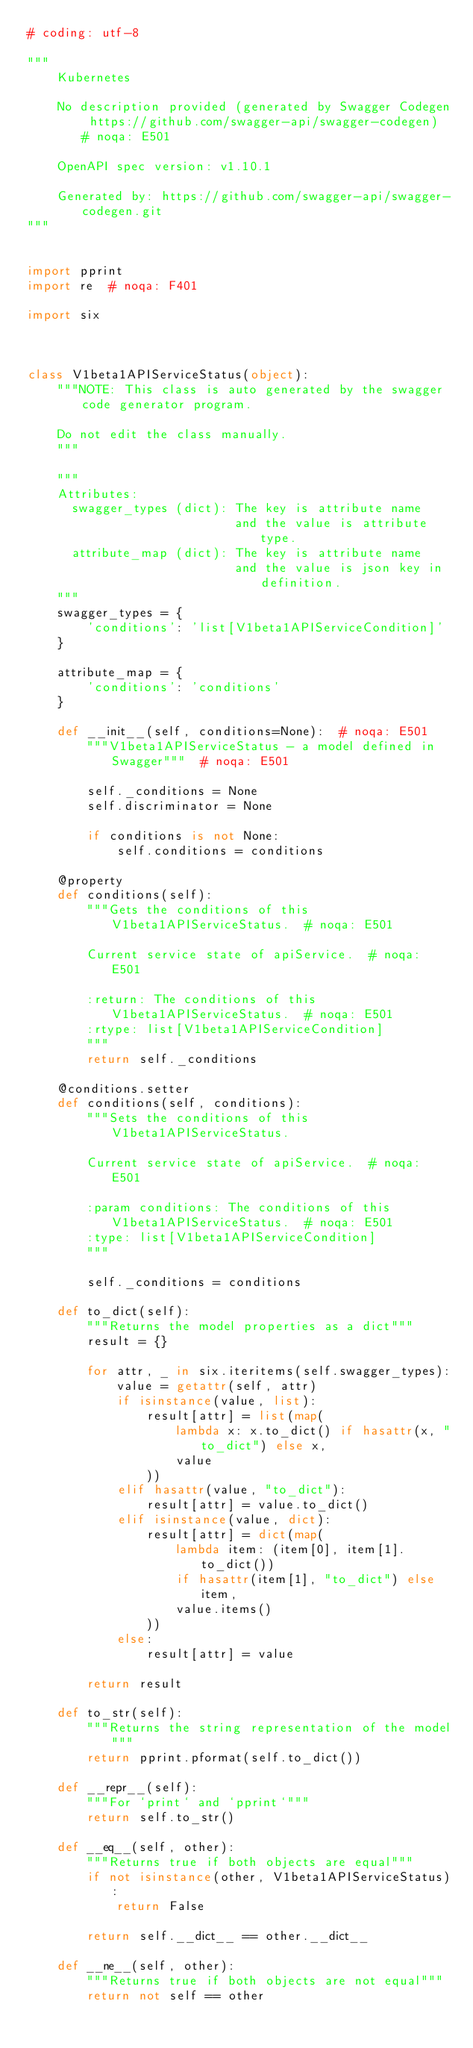Convert code to text. <code><loc_0><loc_0><loc_500><loc_500><_Python_># coding: utf-8

"""
    Kubernetes

    No description provided (generated by Swagger Codegen https://github.com/swagger-api/swagger-codegen)  # noqa: E501

    OpenAPI spec version: v1.10.1
    
    Generated by: https://github.com/swagger-api/swagger-codegen.git
"""


import pprint
import re  # noqa: F401

import six



class V1beta1APIServiceStatus(object):
    """NOTE: This class is auto generated by the swagger code generator program.

    Do not edit the class manually.
    """

    """
    Attributes:
      swagger_types (dict): The key is attribute name
                            and the value is attribute type.
      attribute_map (dict): The key is attribute name
                            and the value is json key in definition.
    """
    swagger_types = {
        'conditions': 'list[V1beta1APIServiceCondition]'
    }

    attribute_map = {
        'conditions': 'conditions'
    }

    def __init__(self, conditions=None):  # noqa: E501
        """V1beta1APIServiceStatus - a model defined in Swagger"""  # noqa: E501

        self._conditions = None
        self.discriminator = None

        if conditions is not None:
            self.conditions = conditions

    @property
    def conditions(self):
        """Gets the conditions of this V1beta1APIServiceStatus.  # noqa: E501

        Current service state of apiService.  # noqa: E501

        :return: The conditions of this V1beta1APIServiceStatus.  # noqa: E501
        :rtype: list[V1beta1APIServiceCondition]
        """
        return self._conditions

    @conditions.setter
    def conditions(self, conditions):
        """Sets the conditions of this V1beta1APIServiceStatus.

        Current service state of apiService.  # noqa: E501

        :param conditions: The conditions of this V1beta1APIServiceStatus.  # noqa: E501
        :type: list[V1beta1APIServiceCondition]
        """

        self._conditions = conditions

    def to_dict(self):
        """Returns the model properties as a dict"""
        result = {}

        for attr, _ in six.iteritems(self.swagger_types):
            value = getattr(self, attr)
            if isinstance(value, list):
                result[attr] = list(map(
                    lambda x: x.to_dict() if hasattr(x, "to_dict") else x,
                    value
                ))
            elif hasattr(value, "to_dict"):
                result[attr] = value.to_dict()
            elif isinstance(value, dict):
                result[attr] = dict(map(
                    lambda item: (item[0], item[1].to_dict())
                    if hasattr(item[1], "to_dict") else item,
                    value.items()
                ))
            else:
                result[attr] = value

        return result

    def to_str(self):
        """Returns the string representation of the model"""
        return pprint.pformat(self.to_dict())

    def __repr__(self):
        """For `print` and `pprint`"""
        return self.to_str()

    def __eq__(self, other):
        """Returns true if both objects are equal"""
        if not isinstance(other, V1beta1APIServiceStatus):
            return False

        return self.__dict__ == other.__dict__

    def __ne__(self, other):
        """Returns true if both objects are not equal"""
        return not self == other
</code> 